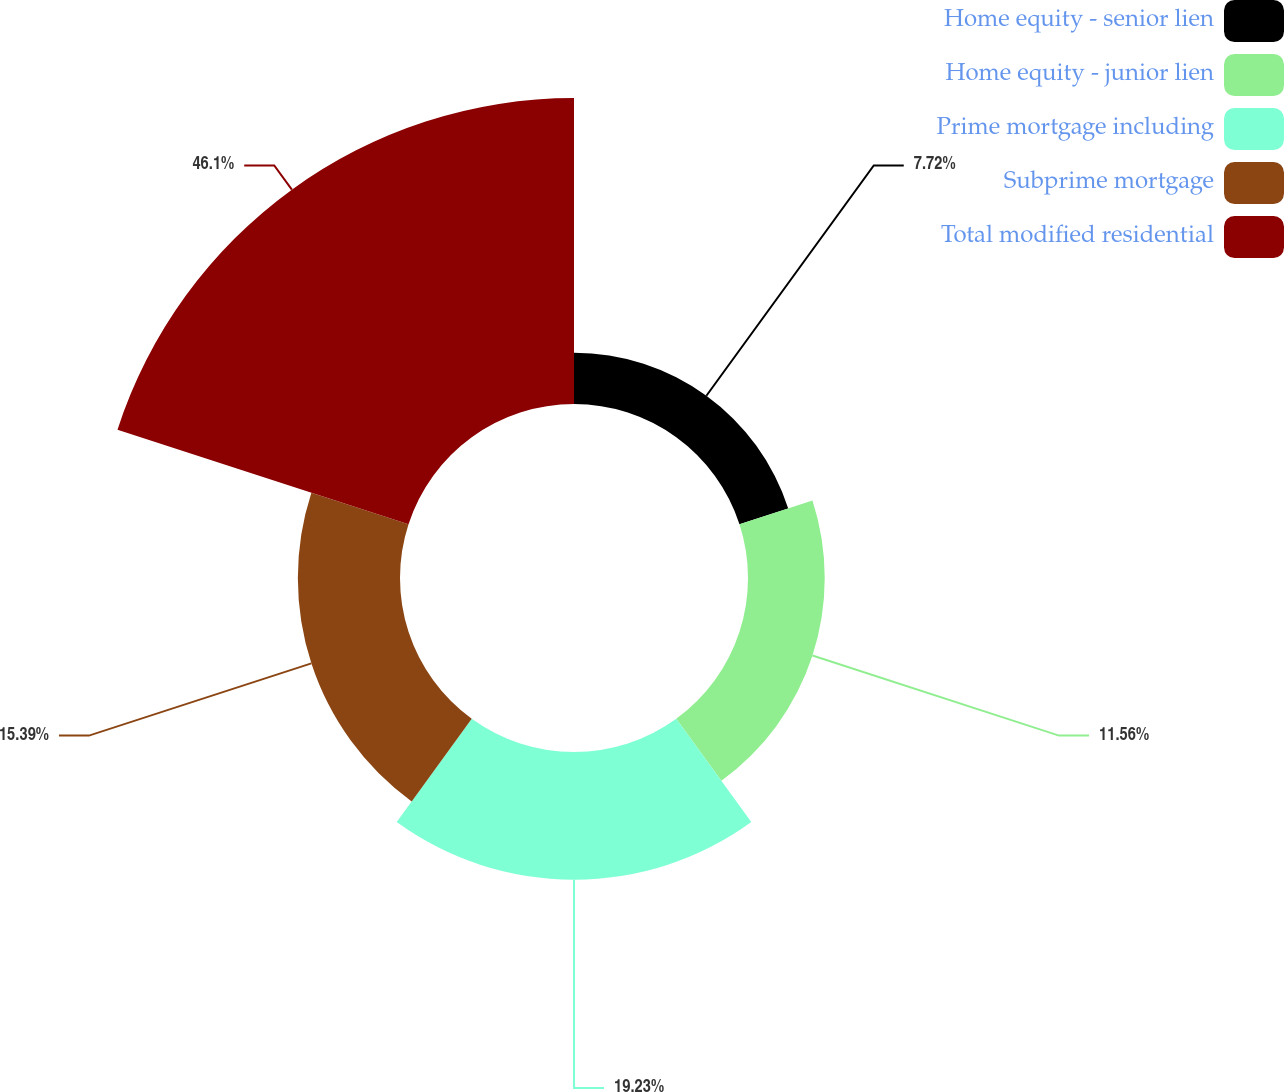<chart> <loc_0><loc_0><loc_500><loc_500><pie_chart><fcel>Home equity - senior lien<fcel>Home equity - junior lien<fcel>Prime mortgage including<fcel>Subprime mortgage<fcel>Total modified residential<nl><fcel>7.72%<fcel>11.56%<fcel>19.23%<fcel>15.39%<fcel>46.1%<nl></chart> 